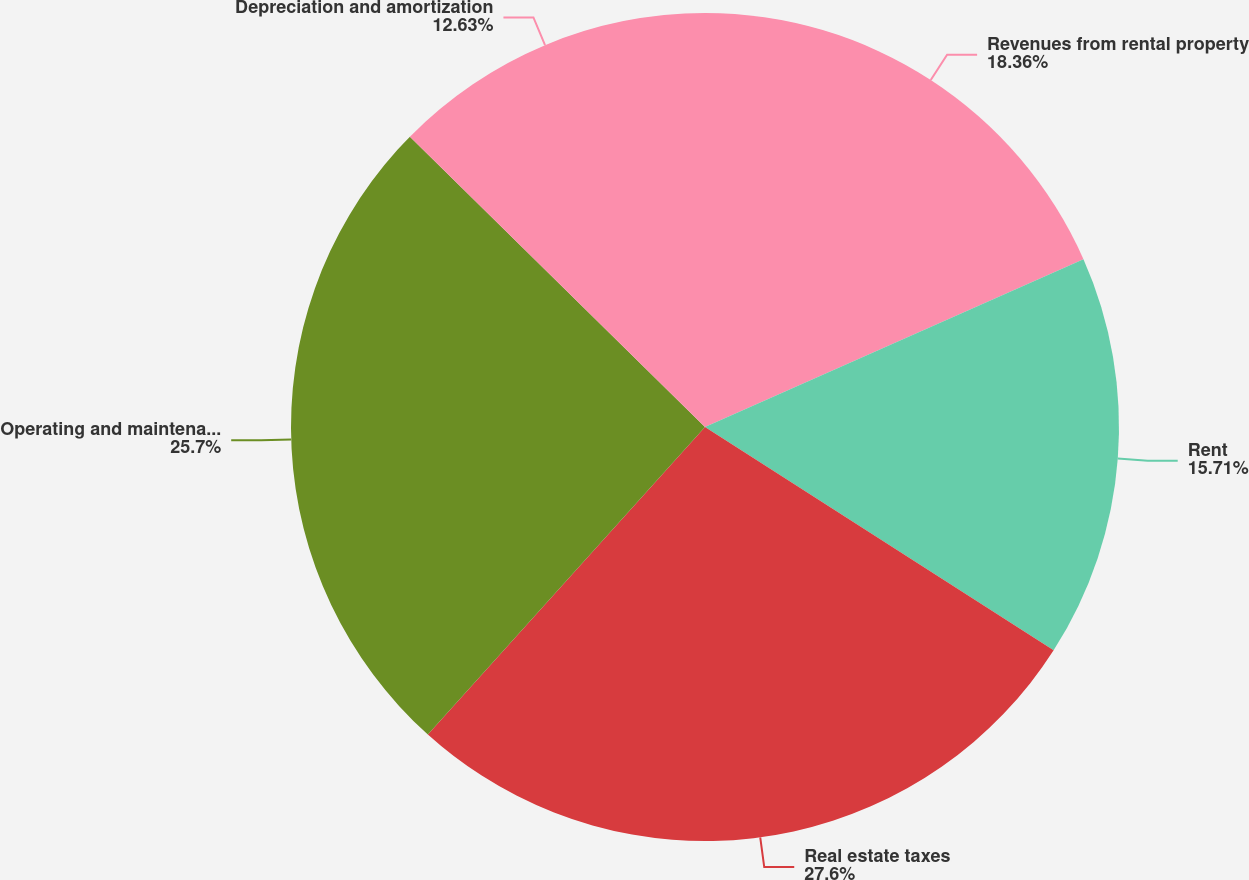Convert chart. <chart><loc_0><loc_0><loc_500><loc_500><pie_chart><fcel>Revenues from rental property<fcel>Rent<fcel>Real estate taxes<fcel>Operating and maintenance<fcel>Depreciation and amortization<nl><fcel>18.36%<fcel>15.71%<fcel>27.61%<fcel>25.7%<fcel>12.63%<nl></chart> 